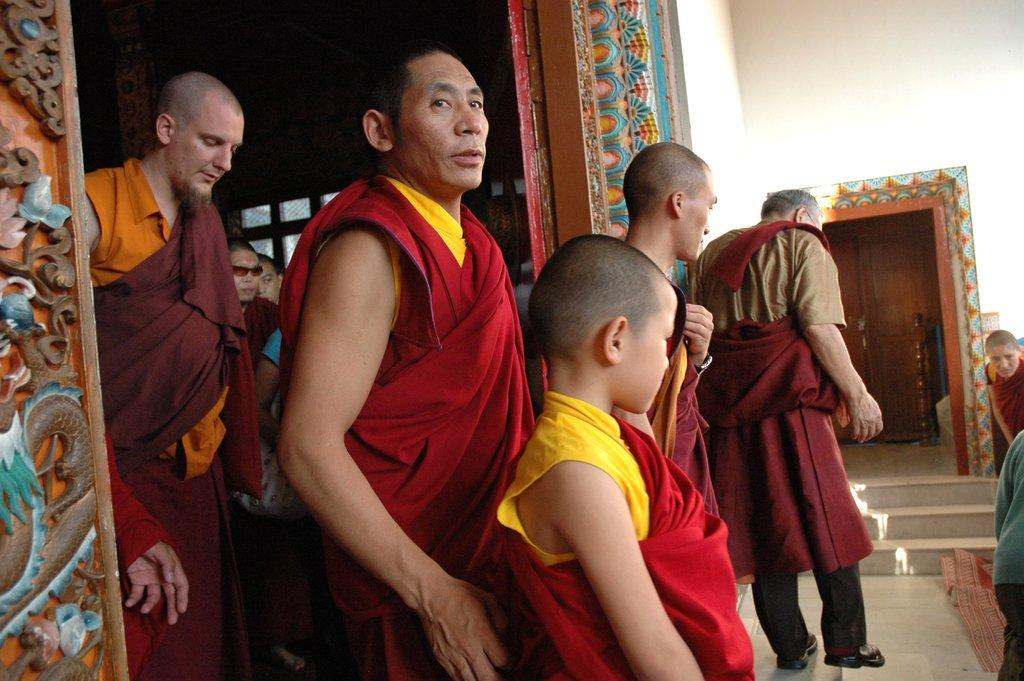Who or what can be seen in the image? There are people in the image. What are the people doing in the image? Some of the people are standing in front of a door. What can be seen behind the people in the image? There is a wall visible in the background of the image. Can you see a stream, basket, or turkey in the image? No, there is no stream, basket, or turkey present in the image. 